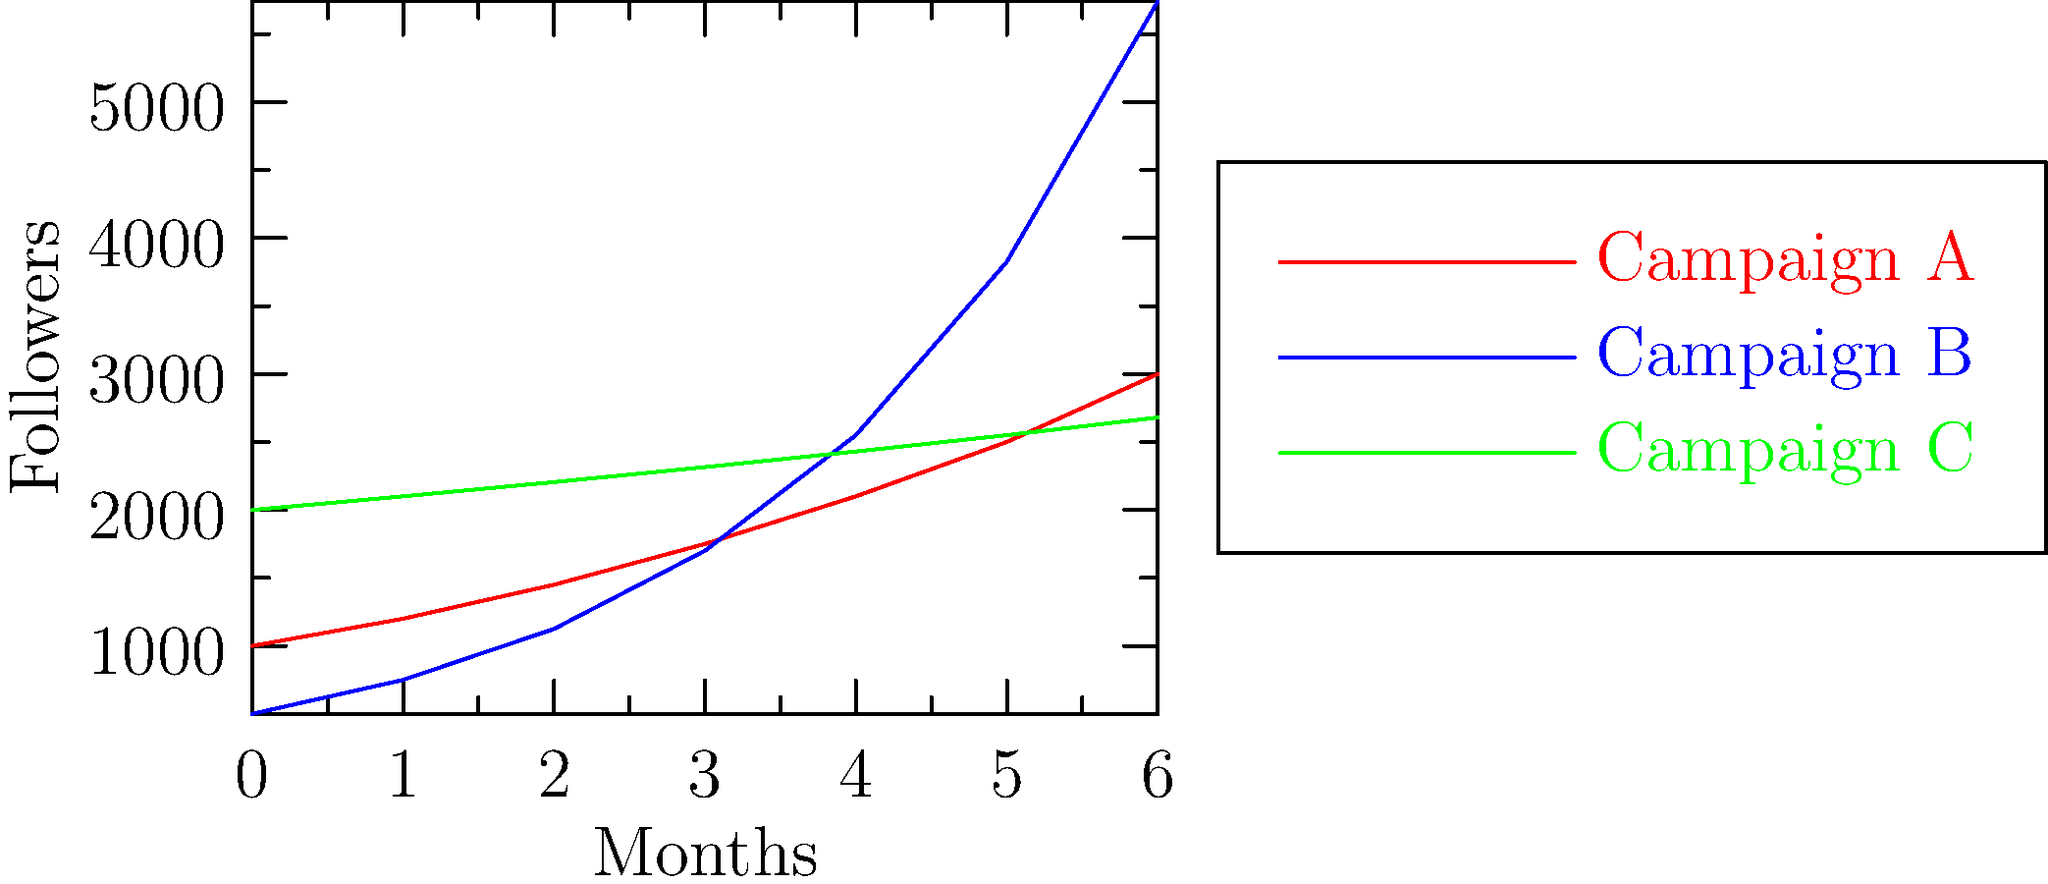The graph shows the growth of social media followers for three different climate campaigns over six months. Which campaign demonstrates exponential growth, and what is its approximate monthly growth rate? To determine which campaign shows exponential growth and its approximate monthly growth rate, we need to analyze the growth patterns of each campaign:

1. Campaign A (red): Shows steady growth but not exponential.
2. Campaign C (green): Shows slow, linear growth.
3. Campaign B (blue): Shows rapid, increasing growth rate, indicative of exponential growth.

For Campaign B, we can calculate the growth rate using the formula:

$\text{Growth Rate} = \left(\frac{\text{Final Value}}{\text{Initial Value}}\right)^{\frac{1}{\text{Number of Periods}}} - 1$

Let's use the initial and final values for Campaign B:
Initial value: 500
Final value: 5740
Number of periods: 6

$\text{Growth Rate} = \left(\frac{5740}{500}\right)^{\frac{1}{6}} - 1$

$\text{Growth Rate} = (11.48)^{\frac{1}{6}} - 1$

$\text{Growth Rate} = 1.5 - 1 = 0.5$

Therefore, the approximate monthly growth rate for Campaign B is 50%.
Answer: Campaign B, 50% 